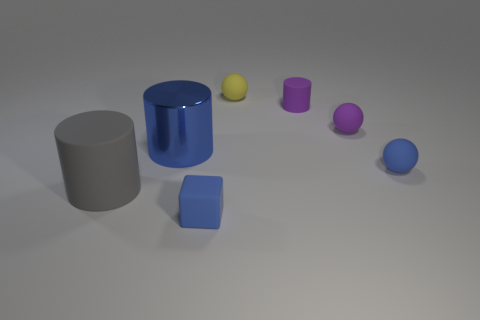What is the color of the cube, and how would you describe its finish? The cube is blue with a matte finish, which contrasts with the shinier surfaces of some other objects in the image. 